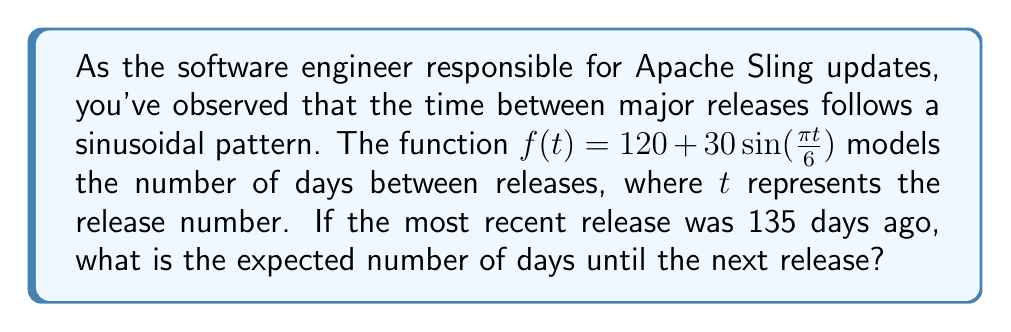Could you help me with this problem? To solve this problem, we need to follow these steps:

1) First, we need to find the inverse of the given function to determine which release number we're currently on. We know that:

   $f(t) = 120 + 30\sin(\frac{\pi t}{6}) = 135$

2) Solving for $t$:
   
   $30\sin(\frac{\pi t}{6}) = 15$
   $\sin(\frac{\pi t}{6}) = 0.5$
   $\frac{\pi t}{6} = \arcsin(0.5) = \frac{\pi}{6}$
   $t = 1$

3) This means we're currently at release number 1 in the cycle.

4) To find the next release, we need to calculate $f(2)$:

   $f(2) = 120 + 30\sin(\frac{\pi \cdot 2}{6})$
   $= 120 + 30\sin(\frac{\pi}{3})$
   $= 120 + 30 \cdot \frac{\sqrt{3}}{2}$
   $= 120 + 15\sqrt{3}$
   $\approx 145.98$

5) The time until the next release is the difference between $f(2)$ and the current time (135 days):

   $145.98 - 135 \approx 10.98$ days
Answer: $\approx 11$ days 